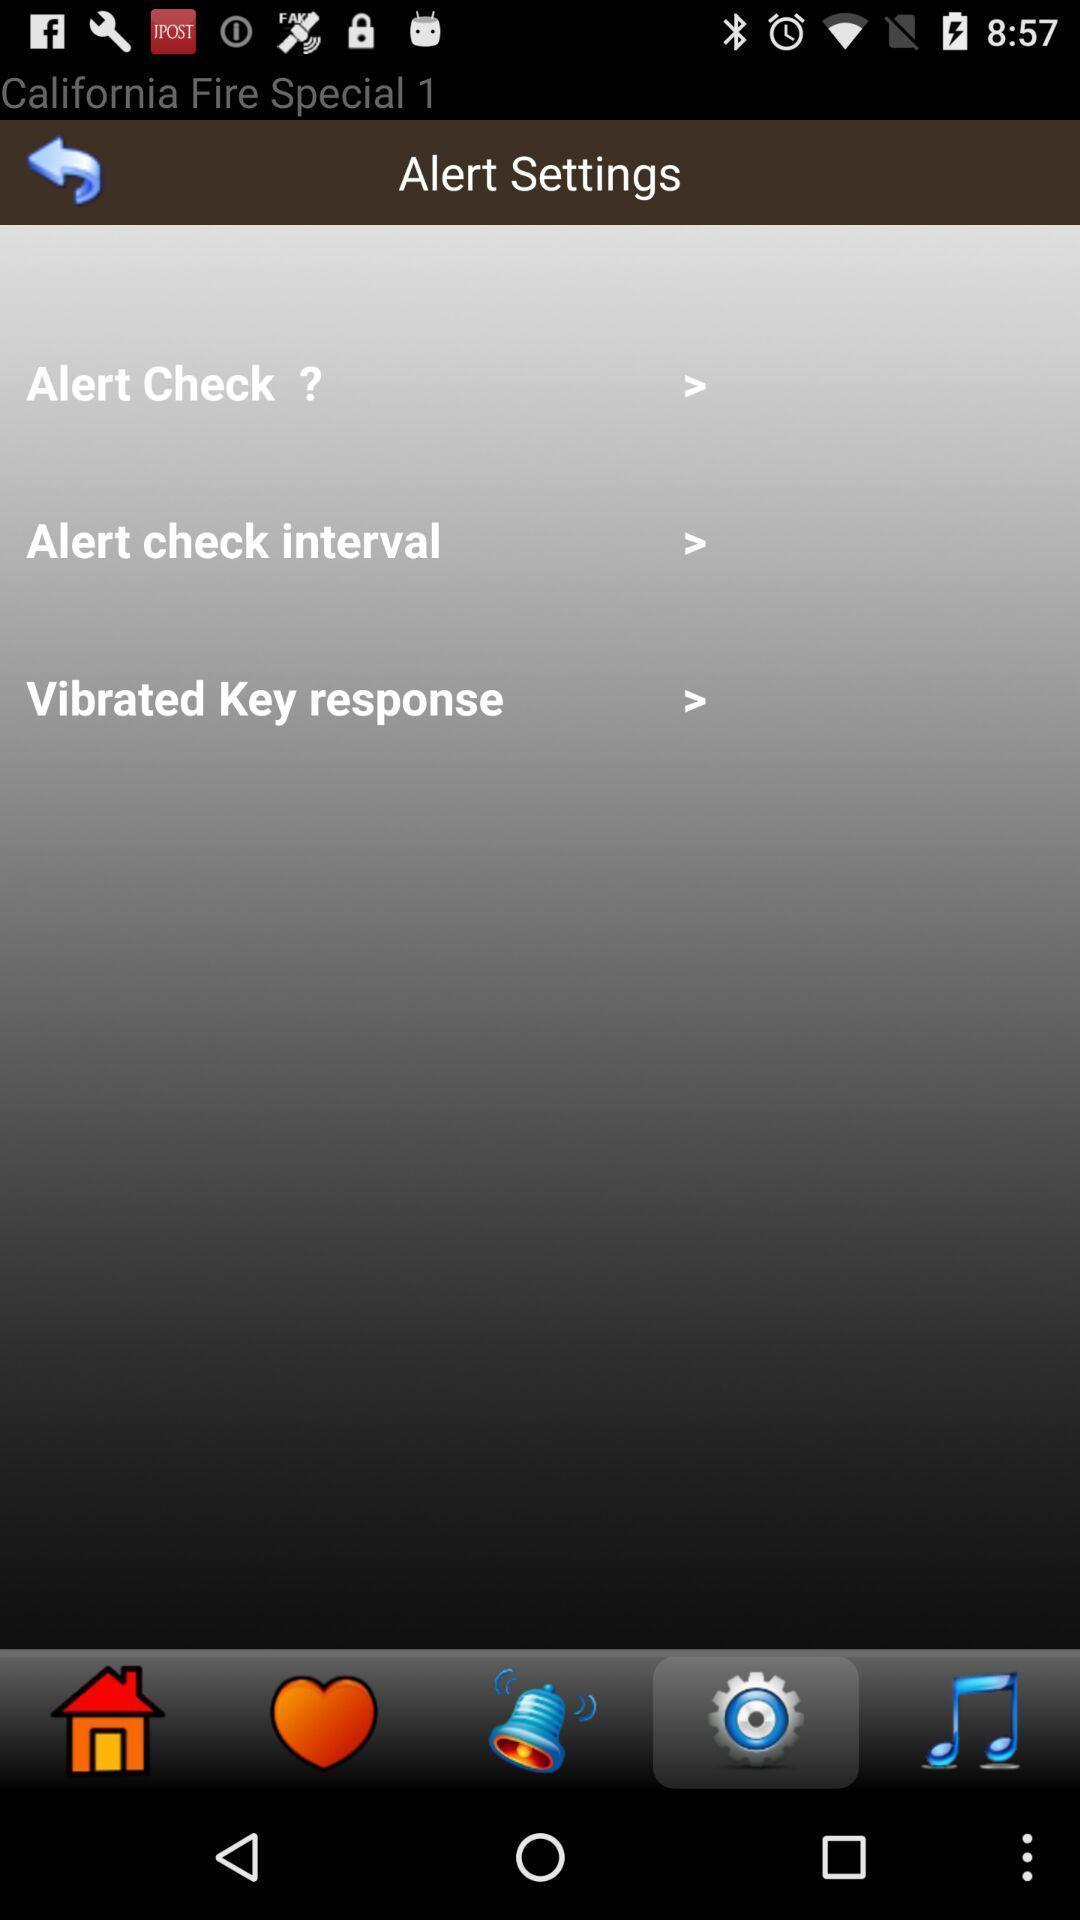Provide a description of this screenshot. Screen page displaying various options. 